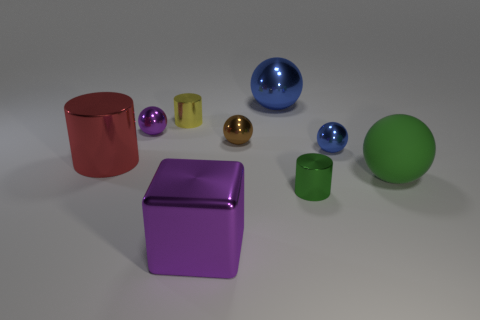Which object in the image appears to be the smallest, and what can you tell about its texture? The smallest object appears to be the golden sphere. It has a shiny, metallic surface that reflects light, suggesting that it might have a smooth and possibly metallic texture. 